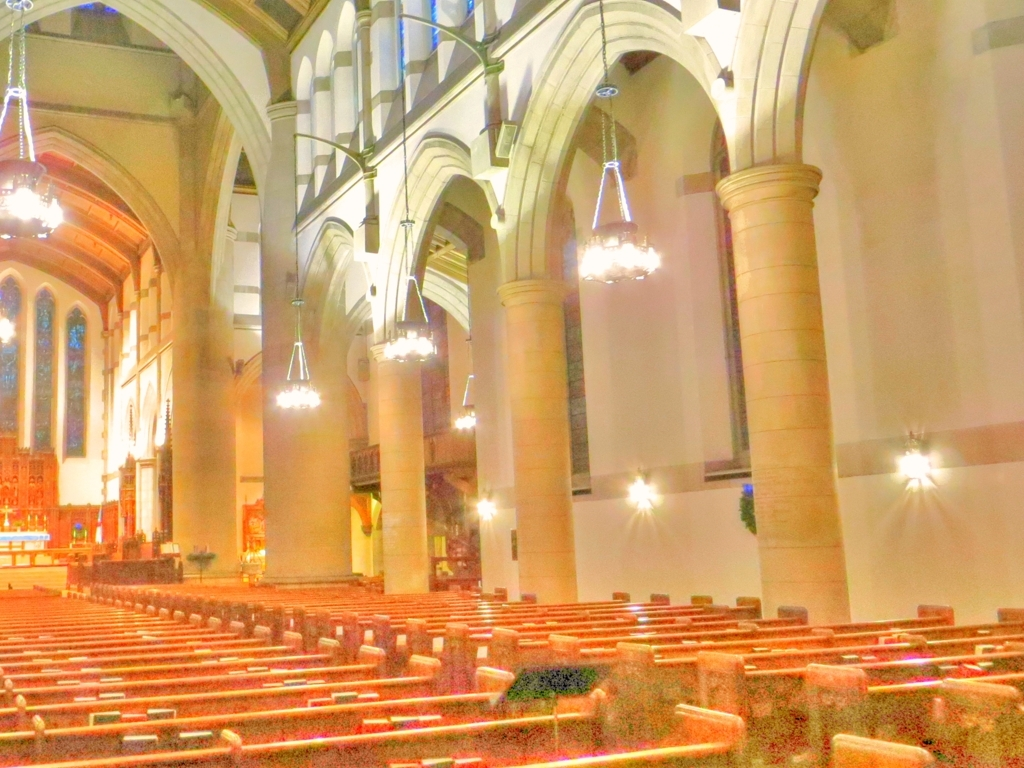Does this image convey a certain mood or atmosphere? The image conveys a tranquil and solemn atmosphere, typical of places of worship. Despite the quality issues with the photograph, the emptiness of the pews and the soft lighting from the chandeliers and wall sconces add to the reflective and peaceful mood. 